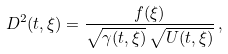Convert formula to latex. <formula><loc_0><loc_0><loc_500><loc_500>D ^ { 2 } ( t , \xi ) = \frac { f ( \xi ) } { \sqrt { \gamma ( t , \xi ) } \, \sqrt { U ( t , \xi ) } } \, ,</formula> 